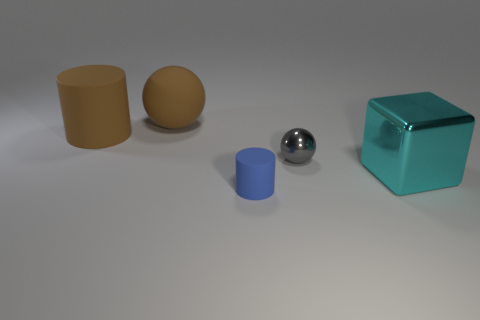Subtract all brown balls. How many balls are left? 1 Subtract all blocks. How many objects are left? 4 Subtract 1 balls. How many balls are left? 1 Subtract all purple cylinders. How many brown spheres are left? 1 Subtract all small blue objects. Subtract all large cyan cubes. How many objects are left? 3 Add 5 gray objects. How many gray objects are left? 6 Add 1 balls. How many balls exist? 3 Add 1 small blue metallic cylinders. How many objects exist? 6 Subtract 0 yellow cylinders. How many objects are left? 5 Subtract all blue blocks. Subtract all purple spheres. How many blocks are left? 1 